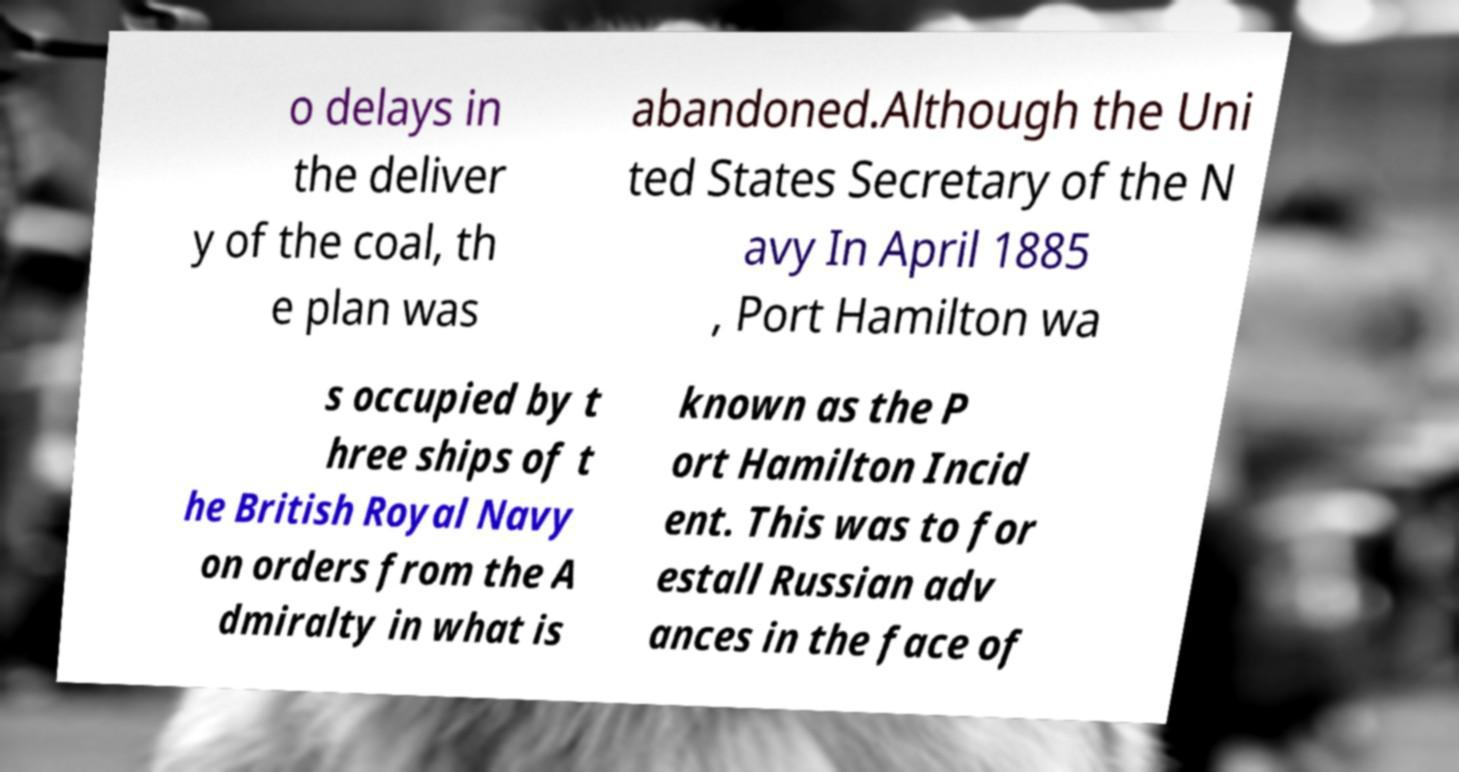Please identify and transcribe the text found in this image. o delays in the deliver y of the coal, th e plan was abandoned.Although the Uni ted States Secretary of the N avy In April 1885 , Port Hamilton wa s occupied by t hree ships of t he British Royal Navy on orders from the A dmiralty in what is known as the P ort Hamilton Incid ent. This was to for estall Russian adv ances in the face of 